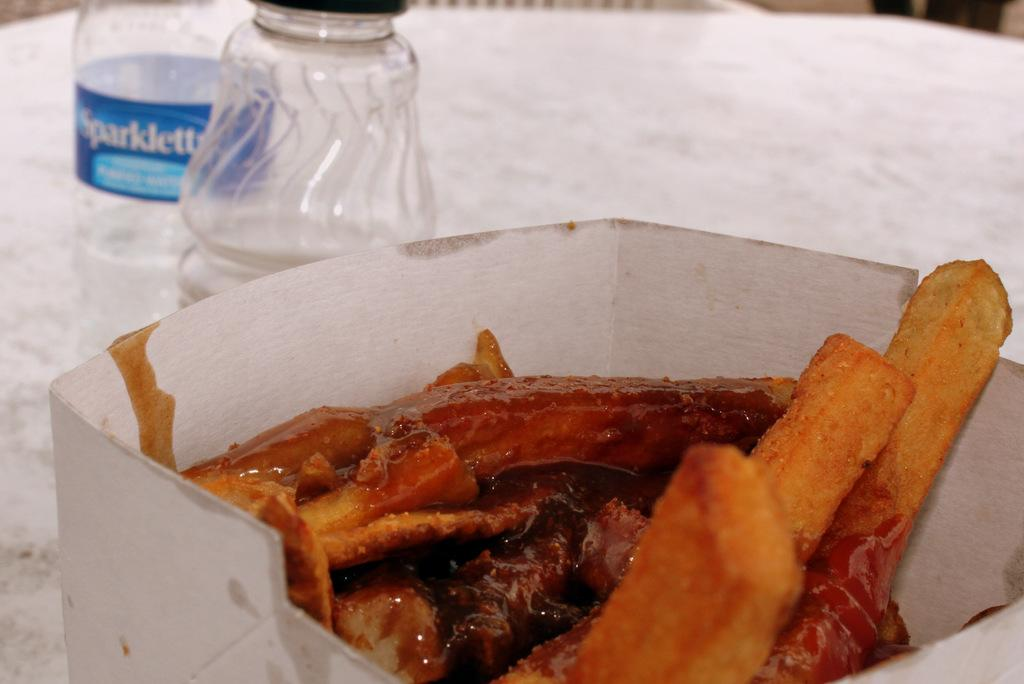<image>
Relay a brief, clear account of the picture shown. A container of bacon along with 2 bottles one of which is Sparklette drinking water. 